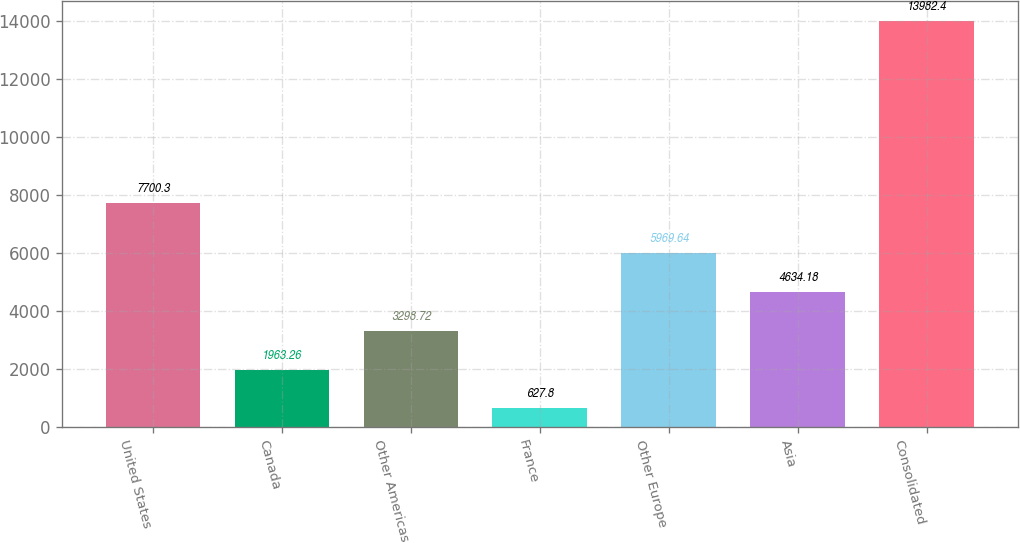Convert chart. <chart><loc_0><loc_0><loc_500><loc_500><bar_chart><fcel>United States<fcel>Canada<fcel>Other Americas<fcel>France<fcel>Other Europe<fcel>Asia<fcel>Consolidated<nl><fcel>7700.3<fcel>1963.26<fcel>3298.72<fcel>627.8<fcel>5969.64<fcel>4634.18<fcel>13982.4<nl></chart> 